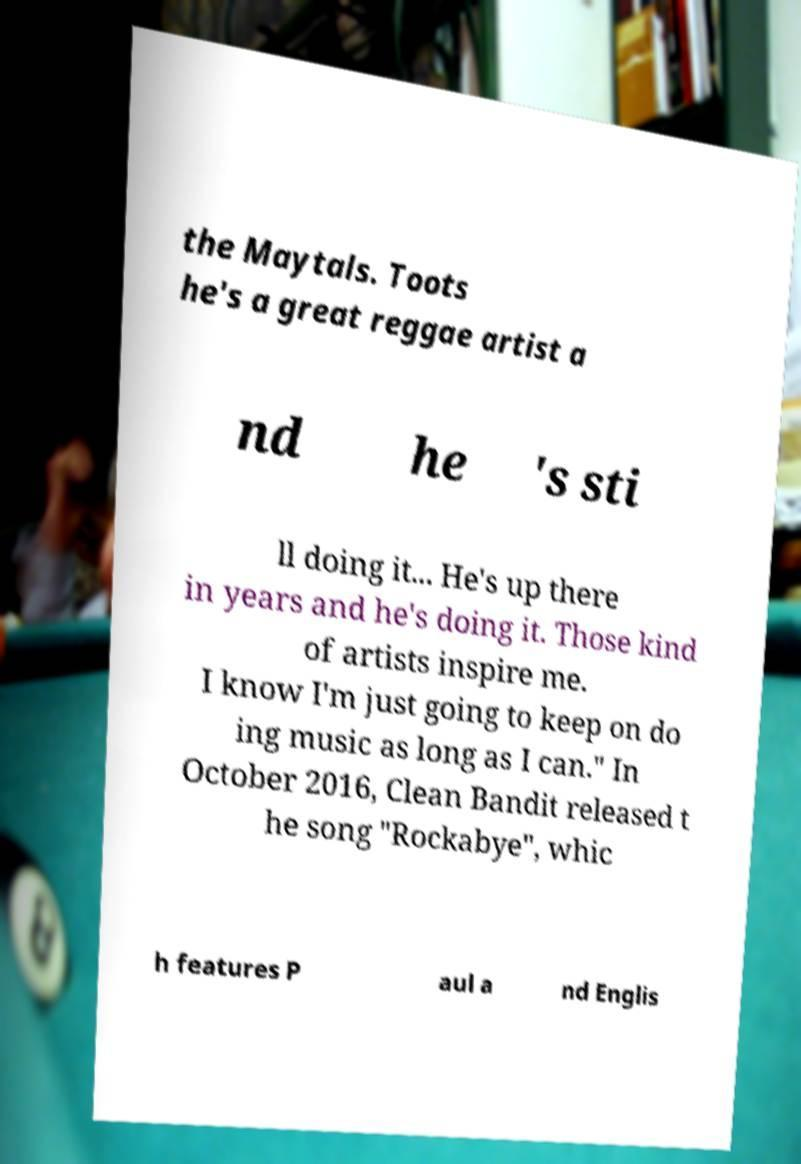Can you accurately transcribe the text from the provided image for me? the Maytals. Toots he's a great reggae artist a nd he 's sti ll doing it... He's up there in years and he's doing it. Those kind of artists inspire me. I know I'm just going to keep on do ing music as long as I can." In October 2016, Clean Bandit released t he song "Rockabye", whic h features P aul a nd Englis 